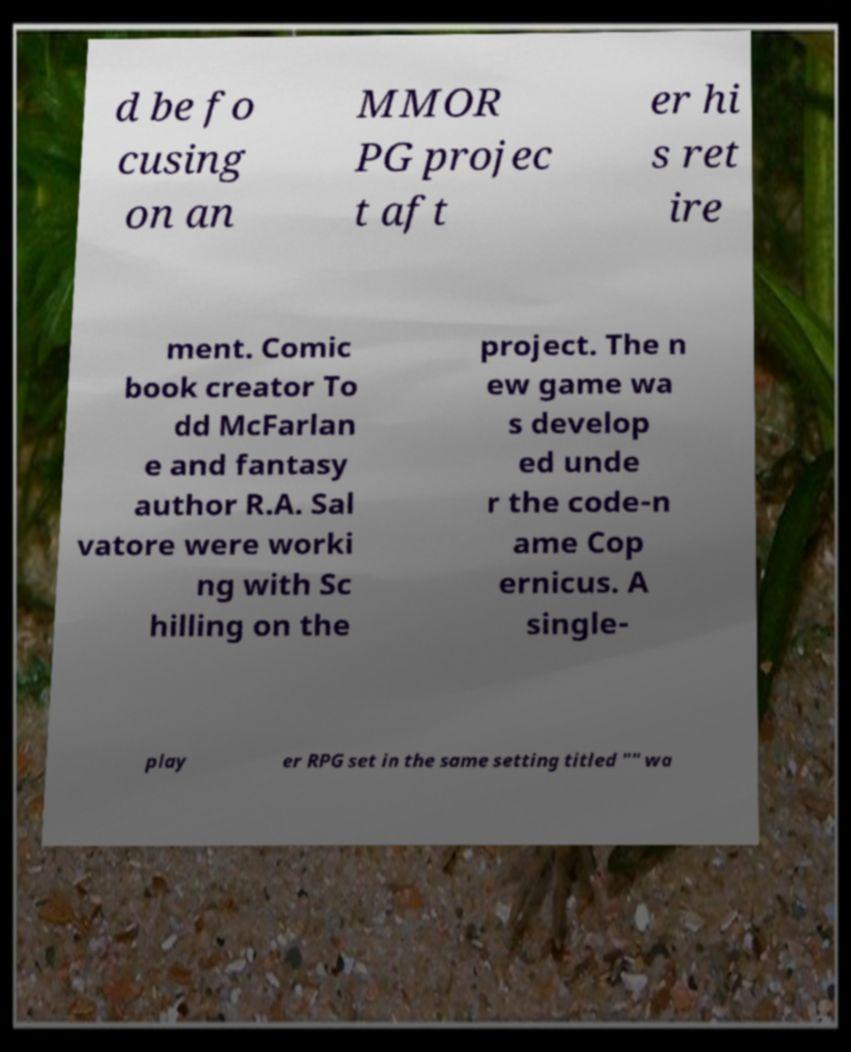Could you extract and type out the text from this image? d be fo cusing on an MMOR PG projec t aft er hi s ret ire ment. Comic book creator To dd McFarlan e and fantasy author R.A. Sal vatore were worki ng with Sc hilling on the project. The n ew game wa s develop ed unde r the code-n ame Cop ernicus. A single- play er RPG set in the same setting titled "" wa 